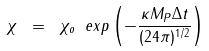<formula> <loc_0><loc_0><loc_500><loc_500>\chi \ = \ \chi _ { o } \ e x p \left ( - \frac { \kappa M _ { P } \Delta t } { ( 2 4 \pi ) ^ { 1 / 2 } } \right )</formula> 